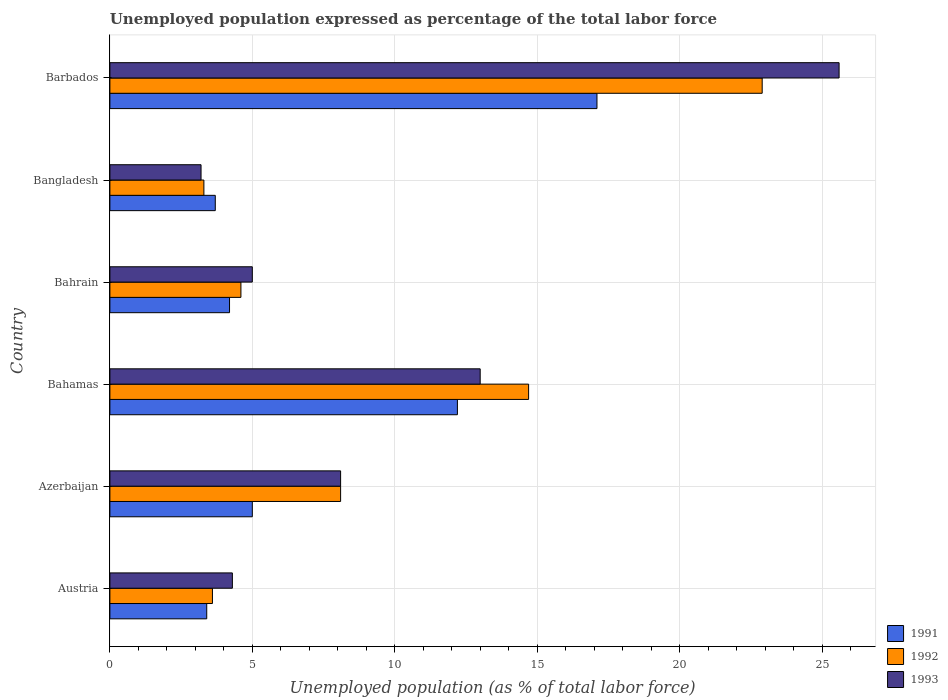Are the number of bars per tick equal to the number of legend labels?
Ensure brevity in your answer.  Yes. What is the label of the 1st group of bars from the top?
Offer a terse response. Barbados. In how many cases, is the number of bars for a given country not equal to the number of legend labels?
Offer a terse response. 0. What is the unemployment in in 1993 in Azerbaijan?
Your answer should be compact. 8.1. Across all countries, what is the maximum unemployment in in 1992?
Provide a succinct answer. 22.9. Across all countries, what is the minimum unemployment in in 1992?
Offer a terse response. 3.3. In which country was the unemployment in in 1993 maximum?
Your answer should be compact. Barbados. In which country was the unemployment in in 1991 minimum?
Provide a succinct answer. Austria. What is the total unemployment in in 1991 in the graph?
Your response must be concise. 45.6. What is the difference between the unemployment in in 1991 in Bahamas and that in Bangladesh?
Your answer should be compact. 8.5. What is the difference between the unemployment in in 1991 in Bahamas and the unemployment in in 1993 in Barbados?
Your answer should be very brief. -13.4. What is the average unemployment in in 1992 per country?
Your answer should be very brief. 9.53. What is the difference between the unemployment in in 1992 and unemployment in in 1993 in Austria?
Your response must be concise. -0.7. What is the ratio of the unemployment in in 1991 in Austria to that in Bangladesh?
Your response must be concise. 0.92. Is the unemployment in in 1993 in Bahamas less than that in Barbados?
Keep it short and to the point. Yes. What is the difference between the highest and the second highest unemployment in in 1992?
Offer a terse response. 8.2. What is the difference between the highest and the lowest unemployment in in 1993?
Keep it short and to the point. 22.4. In how many countries, is the unemployment in in 1991 greater than the average unemployment in in 1991 taken over all countries?
Provide a succinct answer. 2. Is the sum of the unemployment in in 1993 in Azerbaijan and Bangladesh greater than the maximum unemployment in in 1991 across all countries?
Your answer should be very brief. No. What does the 3rd bar from the top in Barbados represents?
Offer a very short reply. 1991. What does the 1st bar from the bottom in Bahamas represents?
Your answer should be very brief. 1991. Are all the bars in the graph horizontal?
Offer a very short reply. Yes. Are the values on the major ticks of X-axis written in scientific E-notation?
Provide a succinct answer. No. Does the graph contain any zero values?
Your answer should be compact. No. Does the graph contain grids?
Ensure brevity in your answer.  Yes. How are the legend labels stacked?
Offer a terse response. Vertical. What is the title of the graph?
Make the answer very short. Unemployed population expressed as percentage of the total labor force. What is the label or title of the X-axis?
Offer a very short reply. Unemployed population (as % of total labor force). What is the label or title of the Y-axis?
Give a very brief answer. Country. What is the Unemployed population (as % of total labor force) in 1991 in Austria?
Give a very brief answer. 3.4. What is the Unemployed population (as % of total labor force) of 1992 in Austria?
Give a very brief answer. 3.6. What is the Unemployed population (as % of total labor force) of 1993 in Austria?
Ensure brevity in your answer.  4.3. What is the Unemployed population (as % of total labor force) in 1991 in Azerbaijan?
Offer a very short reply. 5. What is the Unemployed population (as % of total labor force) of 1992 in Azerbaijan?
Provide a succinct answer. 8.1. What is the Unemployed population (as % of total labor force) in 1993 in Azerbaijan?
Your answer should be very brief. 8.1. What is the Unemployed population (as % of total labor force) in 1991 in Bahamas?
Offer a very short reply. 12.2. What is the Unemployed population (as % of total labor force) in 1992 in Bahamas?
Give a very brief answer. 14.7. What is the Unemployed population (as % of total labor force) of 1991 in Bahrain?
Make the answer very short. 4.2. What is the Unemployed population (as % of total labor force) in 1992 in Bahrain?
Your answer should be compact. 4.6. What is the Unemployed population (as % of total labor force) in 1991 in Bangladesh?
Ensure brevity in your answer.  3.7. What is the Unemployed population (as % of total labor force) in 1992 in Bangladesh?
Offer a terse response. 3.3. What is the Unemployed population (as % of total labor force) of 1993 in Bangladesh?
Keep it short and to the point. 3.2. What is the Unemployed population (as % of total labor force) in 1991 in Barbados?
Provide a short and direct response. 17.1. What is the Unemployed population (as % of total labor force) in 1992 in Barbados?
Ensure brevity in your answer.  22.9. What is the Unemployed population (as % of total labor force) in 1993 in Barbados?
Your response must be concise. 25.6. Across all countries, what is the maximum Unemployed population (as % of total labor force) of 1991?
Your answer should be very brief. 17.1. Across all countries, what is the maximum Unemployed population (as % of total labor force) in 1992?
Provide a short and direct response. 22.9. Across all countries, what is the maximum Unemployed population (as % of total labor force) in 1993?
Provide a short and direct response. 25.6. Across all countries, what is the minimum Unemployed population (as % of total labor force) of 1991?
Keep it short and to the point. 3.4. Across all countries, what is the minimum Unemployed population (as % of total labor force) in 1992?
Your answer should be very brief. 3.3. Across all countries, what is the minimum Unemployed population (as % of total labor force) in 1993?
Provide a short and direct response. 3.2. What is the total Unemployed population (as % of total labor force) in 1991 in the graph?
Keep it short and to the point. 45.6. What is the total Unemployed population (as % of total labor force) in 1992 in the graph?
Give a very brief answer. 57.2. What is the total Unemployed population (as % of total labor force) of 1993 in the graph?
Keep it short and to the point. 59.2. What is the difference between the Unemployed population (as % of total labor force) in 1992 in Austria and that in Azerbaijan?
Your answer should be compact. -4.5. What is the difference between the Unemployed population (as % of total labor force) of 1993 in Austria and that in Azerbaijan?
Offer a very short reply. -3.8. What is the difference between the Unemployed population (as % of total labor force) in 1993 in Austria and that in Bahamas?
Your answer should be compact. -8.7. What is the difference between the Unemployed population (as % of total labor force) in 1991 in Austria and that in Bahrain?
Give a very brief answer. -0.8. What is the difference between the Unemployed population (as % of total labor force) of 1992 in Austria and that in Bahrain?
Provide a succinct answer. -1. What is the difference between the Unemployed population (as % of total labor force) of 1991 in Austria and that in Barbados?
Offer a very short reply. -13.7. What is the difference between the Unemployed population (as % of total labor force) in 1992 in Austria and that in Barbados?
Your answer should be compact. -19.3. What is the difference between the Unemployed population (as % of total labor force) in 1993 in Austria and that in Barbados?
Provide a short and direct response. -21.3. What is the difference between the Unemployed population (as % of total labor force) in 1991 in Azerbaijan and that in Bahamas?
Provide a short and direct response. -7.2. What is the difference between the Unemployed population (as % of total labor force) of 1992 in Azerbaijan and that in Bahamas?
Keep it short and to the point. -6.6. What is the difference between the Unemployed population (as % of total labor force) in 1992 in Azerbaijan and that in Bahrain?
Make the answer very short. 3.5. What is the difference between the Unemployed population (as % of total labor force) of 1991 in Azerbaijan and that in Barbados?
Give a very brief answer. -12.1. What is the difference between the Unemployed population (as % of total labor force) of 1992 in Azerbaijan and that in Barbados?
Provide a short and direct response. -14.8. What is the difference between the Unemployed population (as % of total labor force) in 1993 in Azerbaijan and that in Barbados?
Your answer should be compact. -17.5. What is the difference between the Unemployed population (as % of total labor force) in 1993 in Bahamas and that in Bahrain?
Your answer should be very brief. 8. What is the difference between the Unemployed population (as % of total labor force) of 1991 in Bahamas and that in Bangladesh?
Provide a succinct answer. 8.5. What is the difference between the Unemployed population (as % of total labor force) of 1992 in Bahamas and that in Bangladesh?
Ensure brevity in your answer.  11.4. What is the difference between the Unemployed population (as % of total labor force) in 1993 in Bahamas and that in Bangladesh?
Offer a terse response. 9.8. What is the difference between the Unemployed population (as % of total labor force) in 1991 in Bahamas and that in Barbados?
Keep it short and to the point. -4.9. What is the difference between the Unemployed population (as % of total labor force) of 1992 in Bahamas and that in Barbados?
Your response must be concise. -8.2. What is the difference between the Unemployed population (as % of total labor force) of 1993 in Bahamas and that in Barbados?
Provide a short and direct response. -12.6. What is the difference between the Unemployed population (as % of total labor force) in 1993 in Bahrain and that in Bangladesh?
Provide a succinct answer. 1.8. What is the difference between the Unemployed population (as % of total labor force) of 1992 in Bahrain and that in Barbados?
Offer a very short reply. -18.3. What is the difference between the Unemployed population (as % of total labor force) in 1993 in Bahrain and that in Barbados?
Give a very brief answer. -20.6. What is the difference between the Unemployed population (as % of total labor force) of 1992 in Bangladesh and that in Barbados?
Make the answer very short. -19.6. What is the difference between the Unemployed population (as % of total labor force) of 1993 in Bangladesh and that in Barbados?
Your response must be concise. -22.4. What is the difference between the Unemployed population (as % of total labor force) in 1991 in Austria and the Unemployed population (as % of total labor force) in 1992 in Azerbaijan?
Offer a terse response. -4.7. What is the difference between the Unemployed population (as % of total labor force) of 1991 in Austria and the Unemployed population (as % of total labor force) of 1993 in Azerbaijan?
Provide a succinct answer. -4.7. What is the difference between the Unemployed population (as % of total labor force) in 1992 in Austria and the Unemployed population (as % of total labor force) in 1993 in Azerbaijan?
Make the answer very short. -4.5. What is the difference between the Unemployed population (as % of total labor force) in 1992 in Austria and the Unemployed population (as % of total labor force) in 1993 in Bahamas?
Make the answer very short. -9.4. What is the difference between the Unemployed population (as % of total labor force) of 1991 in Austria and the Unemployed population (as % of total labor force) of 1992 in Bahrain?
Your answer should be very brief. -1.2. What is the difference between the Unemployed population (as % of total labor force) of 1992 in Austria and the Unemployed population (as % of total labor force) of 1993 in Bahrain?
Offer a terse response. -1.4. What is the difference between the Unemployed population (as % of total labor force) of 1991 in Austria and the Unemployed population (as % of total labor force) of 1992 in Barbados?
Ensure brevity in your answer.  -19.5. What is the difference between the Unemployed population (as % of total labor force) of 1991 in Austria and the Unemployed population (as % of total labor force) of 1993 in Barbados?
Make the answer very short. -22.2. What is the difference between the Unemployed population (as % of total labor force) in 1992 in Austria and the Unemployed population (as % of total labor force) in 1993 in Barbados?
Keep it short and to the point. -22. What is the difference between the Unemployed population (as % of total labor force) of 1991 in Azerbaijan and the Unemployed population (as % of total labor force) of 1993 in Bahamas?
Your answer should be very brief. -8. What is the difference between the Unemployed population (as % of total labor force) of 1991 in Azerbaijan and the Unemployed population (as % of total labor force) of 1993 in Bahrain?
Your answer should be very brief. 0. What is the difference between the Unemployed population (as % of total labor force) in 1992 in Azerbaijan and the Unemployed population (as % of total labor force) in 1993 in Bahrain?
Keep it short and to the point. 3.1. What is the difference between the Unemployed population (as % of total labor force) of 1991 in Azerbaijan and the Unemployed population (as % of total labor force) of 1993 in Bangladesh?
Make the answer very short. 1.8. What is the difference between the Unemployed population (as % of total labor force) in 1992 in Azerbaijan and the Unemployed population (as % of total labor force) in 1993 in Bangladesh?
Your answer should be compact. 4.9. What is the difference between the Unemployed population (as % of total labor force) of 1991 in Azerbaijan and the Unemployed population (as % of total labor force) of 1992 in Barbados?
Ensure brevity in your answer.  -17.9. What is the difference between the Unemployed population (as % of total labor force) of 1991 in Azerbaijan and the Unemployed population (as % of total labor force) of 1993 in Barbados?
Offer a very short reply. -20.6. What is the difference between the Unemployed population (as % of total labor force) in 1992 in Azerbaijan and the Unemployed population (as % of total labor force) in 1993 in Barbados?
Provide a succinct answer. -17.5. What is the difference between the Unemployed population (as % of total labor force) in 1991 in Bahamas and the Unemployed population (as % of total labor force) in 1992 in Bahrain?
Your answer should be very brief. 7.6. What is the difference between the Unemployed population (as % of total labor force) in 1992 in Bahamas and the Unemployed population (as % of total labor force) in 1993 in Bangladesh?
Provide a short and direct response. 11.5. What is the difference between the Unemployed population (as % of total labor force) of 1991 in Bahamas and the Unemployed population (as % of total labor force) of 1993 in Barbados?
Offer a terse response. -13.4. What is the difference between the Unemployed population (as % of total labor force) of 1992 in Bahamas and the Unemployed population (as % of total labor force) of 1993 in Barbados?
Offer a terse response. -10.9. What is the difference between the Unemployed population (as % of total labor force) in 1991 in Bahrain and the Unemployed population (as % of total labor force) in 1993 in Bangladesh?
Provide a short and direct response. 1. What is the difference between the Unemployed population (as % of total labor force) of 1991 in Bahrain and the Unemployed population (as % of total labor force) of 1992 in Barbados?
Your answer should be compact. -18.7. What is the difference between the Unemployed population (as % of total labor force) of 1991 in Bahrain and the Unemployed population (as % of total labor force) of 1993 in Barbados?
Give a very brief answer. -21.4. What is the difference between the Unemployed population (as % of total labor force) of 1991 in Bangladesh and the Unemployed population (as % of total labor force) of 1992 in Barbados?
Offer a terse response. -19.2. What is the difference between the Unemployed population (as % of total labor force) of 1991 in Bangladesh and the Unemployed population (as % of total labor force) of 1993 in Barbados?
Your answer should be very brief. -21.9. What is the difference between the Unemployed population (as % of total labor force) in 1992 in Bangladesh and the Unemployed population (as % of total labor force) in 1993 in Barbados?
Your answer should be very brief. -22.3. What is the average Unemployed population (as % of total labor force) of 1992 per country?
Ensure brevity in your answer.  9.53. What is the average Unemployed population (as % of total labor force) in 1993 per country?
Your answer should be very brief. 9.87. What is the difference between the Unemployed population (as % of total labor force) of 1991 and Unemployed population (as % of total labor force) of 1992 in Austria?
Offer a very short reply. -0.2. What is the difference between the Unemployed population (as % of total labor force) in 1991 and Unemployed population (as % of total labor force) in 1993 in Azerbaijan?
Ensure brevity in your answer.  -3.1. What is the difference between the Unemployed population (as % of total labor force) in 1992 and Unemployed population (as % of total labor force) in 1993 in Azerbaijan?
Your answer should be compact. 0. What is the difference between the Unemployed population (as % of total labor force) of 1991 and Unemployed population (as % of total labor force) of 1992 in Bahamas?
Give a very brief answer. -2.5. What is the difference between the Unemployed population (as % of total labor force) of 1991 and Unemployed population (as % of total labor force) of 1993 in Bahamas?
Provide a succinct answer. -0.8. What is the difference between the Unemployed population (as % of total labor force) of 1991 and Unemployed population (as % of total labor force) of 1992 in Bahrain?
Ensure brevity in your answer.  -0.4. What is the difference between the Unemployed population (as % of total labor force) of 1991 and Unemployed population (as % of total labor force) of 1992 in Bangladesh?
Your response must be concise. 0.4. What is the difference between the Unemployed population (as % of total labor force) of 1991 and Unemployed population (as % of total labor force) of 1993 in Bangladesh?
Give a very brief answer. 0.5. What is the difference between the Unemployed population (as % of total labor force) of 1992 and Unemployed population (as % of total labor force) of 1993 in Bangladesh?
Provide a succinct answer. 0.1. What is the difference between the Unemployed population (as % of total labor force) of 1992 and Unemployed population (as % of total labor force) of 1993 in Barbados?
Your answer should be very brief. -2.7. What is the ratio of the Unemployed population (as % of total labor force) in 1991 in Austria to that in Azerbaijan?
Make the answer very short. 0.68. What is the ratio of the Unemployed population (as % of total labor force) in 1992 in Austria to that in Azerbaijan?
Your answer should be very brief. 0.44. What is the ratio of the Unemployed population (as % of total labor force) of 1993 in Austria to that in Azerbaijan?
Provide a succinct answer. 0.53. What is the ratio of the Unemployed population (as % of total labor force) of 1991 in Austria to that in Bahamas?
Offer a terse response. 0.28. What is the ratio of the Unemployed population (as % of total labor force) of 1992 in Austria to that in Bahamas?
Offer a terse response. 0.24. What is the ratio of the Unemployed population (as % of total labor force) of 1993 in Austria to that in Bahamas?
Your response must be concise. 0.33. What is the ratio of the Unemployed population (as % of total labor force) of 1991 in Austria to that in Bahrain?
Make the answer very short. 0.81. What is the ratio of the Unemployed population (as % of total labor force) in 1992 in Austria to that in Bahrain?
Ensure brevity in your answer.  0.78. What is the ratio of the Unemployed population (as % of total labor force) in 1993 in Austria to that in Bahrain?
Provide a succinct answer. 0.86. What is the ratio of the Unemployed population (as % of total labor force) of 1991 in Austria to that in Bangladesh?
Offer a very short reply. 0.92. What is the ratio of the Unemployed population (as % of total labor force) in 1992 in Austria to that in Bangladesh?
Give a very brief answer. 1.09. What is the ratio of the Unemployed population (as % of total labor force) in 1993 in Austria to that in Bangladesh?
Your answer should be very brief. 1.34. What is the ratio of the Unemployed population (as % of total labor force) of 1991 in Austria to that in Barbados?
Keep it short and to the point. 0.2. What is the ratio of the Unemployed population (as % of total labor force) of 1992 in Austria to that in Barbados?
Give a very brief answer. 0.16. What is the ratio of the Unemployed population (as % of total labor force) of 1993 in Austria to that in Barbados?
Your answer should be compact. 0.17. What is the ratio of the Unemployed population (as % of total labor force) of 1991 in Azerbaijan to that in Bahamas?
Keep it short and to the point. 0.41. What is the ratio of the Unemployed population (as % of total labor force) in 1992 in Azerbaijan to that in Bahamas?
Provide a succinct answer. 0.55. What is the ratio of the Unemployed population (as % of total labor force) of 1993 in Azerbaijan to that in Bahamas?
Your answer should be very brief. 0.62. What is the ratio of the Unemployed population (as % of total labor force) of 1991 in Azerbaijan to that in Bahrain?
Offer a very short reply. 1.19. What is the ratio of the Unemployed population (as % of total labor force) in 1992 in Azerbaijan to that in Bahrain?
Offer a very short reply. 1.76. What is the ratio of the Unemployed population (as % of total labor force) in 1993 in Azerbaijan to that in Bahrain?
Provide a short and direct response. 1.62. What is the ratio of the Unemployed population (as % of total labor force) of 1991 in Azerbaijan to that in Bangladesh?
Your answer should be compact. 1.35. What is the ratio of the Unemployed population (as % of total labor force) of 1992 in Azerbaijan to that in Bangladesh?
Your answer should be compact. 2.45. What is the ratio of the Unemployed population (as % of total labor force) in 1993 in Azerbaijan to that in Bangladesh?
Provide a succinct answer. 2.53. What is the ratio of the Unemployed population (as % of total labor force) of 1991 in Azerbaijan to that in Barbados?
Provide a succinct answer. 0.29. What is the ratio of the Unemployed population (as % of total labor force) of 1992 in Azerbaijan to that in Barbados?
Keep it short and to the point. 0.35. What is the ratio of the Unemployed population (as % of total labor force) of 1993 in Azerbaijan to that in Barbados?
Offer a very short reply. 0.32. What is the ratio of the Unemployed population (as % of total labor force) of 1991 in Bahamas to that in Bahrain?
Ensure brevity in your answer.  2.9. What is the ratio of the Unemployed population (as % of total labor force) of 1992 in Bahamas to that in Bahrain?
Give a very brief answer. 3.2. What is the ratio of the Unemployed population (as % of total labor force) in 1991 in Bahamas to that in Bangladesh?
Provide a succinct answer. 3.3. What is the ratio of the Unemployed population (as % of total labor force) in 1992 in Bahamas to that in Bangladesh?
Your answer should be very brief. 4.45. What is the ratio of the Unemployed population (as % of total labor force) in 1993 in Bahamas to that in Bangladesh?
Ensure brevity in your answer.  4.06. What is the ratio of the Unemployed population (as % of total labor force) in 1991 in Bahamas to that in Barbados?
Your response must be concise. 0.71. What is the ratio of the Unemployed population (as % of total labor force) in 1992 in Bahamas to that in Barbados?
Provide a short and direct response. 0.64. What is the ratio of the Unemployed population (as % of total labor force) of 1993 in Bahamas to that in Barbados?
Provide a succinct answer. 0.51. What is the ratio of the Unemployed population (as % of total labor force) in 1991 in Bahrain to that in Bangladesh?
Your response must be concise. 1.14. What is the ratio of the Unemployed population (as % of total labor force) in 1992 in Bahrain to that in Bangladesh?
Provide a succinct answer. 1.39. What is the ratio of the Unemployed population (as % of total labor force) in 1993 in Bahrain to that in Bangladesh?
Offer a very short reply. 1.56. What is the ratio of the Unemployed population (as % of total labor force) of 1991 in Bahrain to that in Barbados?
Your answer should be very brief. 0.25. What is the ratio of the Unemployed population (as % of total labor force) in 1992 in Bahrain to that in Barbados?
Provide a succinct answer. 0.2. What is the ratio of the Unemployed population (as % of total labor force) in 1993 in Bahrain to that in Barbados?
Provide a short and direct response. 0.2. What is the ratio of the Unemployed population (as % of total labor force) in 1991 in Bangladesh to that in Barbados?
Offer a terse response. 0.22. What is the ratio of the Unemployed population (as % of total labor force) of 1992 in Bangladesh to that in Barbados?
Give a very brief answer. 0.14. What is the ratio of the Unemployed population (as % of total labor force) in 1993 in Bangladesh to that in Barbados?
Keep it short and to the point. 0.12. What is the difference between the highest and the lowest Unemployed population (as % of total labor force) in 1991?
Offer a very short reply. 13.7. What is the difference between the highest and the lowest Unemployed population (as % of total labor force) in 1992?
Your answer should be very brief. 19.6. What is the difference between the highest and the lowest Unemployed population (as % of total labor force) in 1993?
Give a very brief answer. 22.4. 